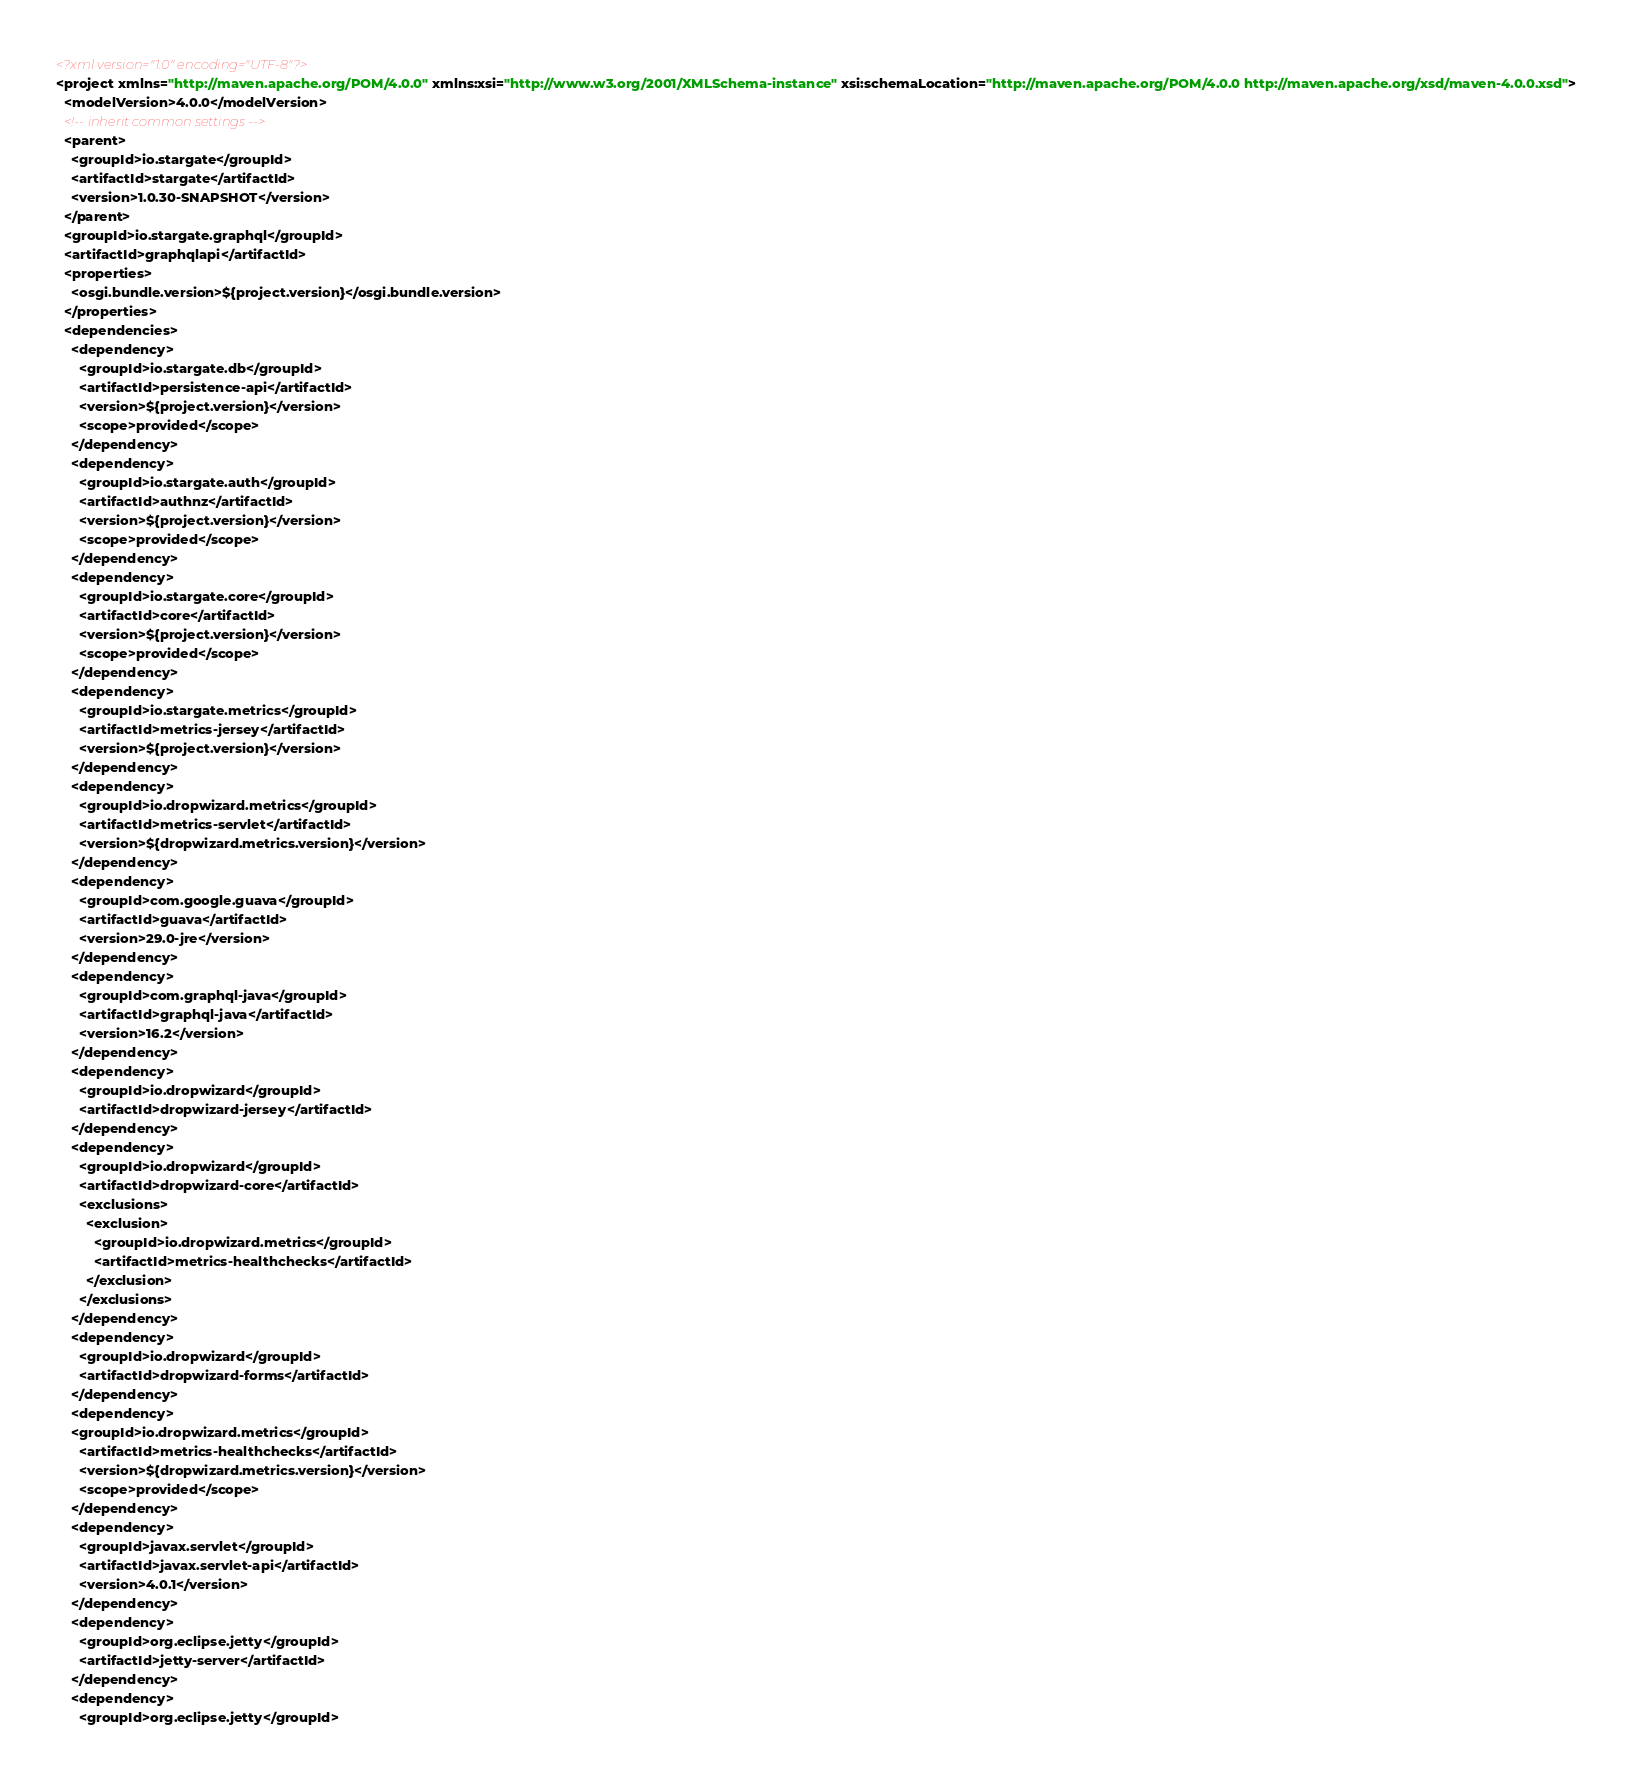<code> <loc_0><loc_0><loc_500><loc_500><_XML_><?xml version="1.0" encoding="UTF-8"?>
<project xmlns="http://maven.apache.org/POM/4.0.0" xmlns:xsi="http://www.w3.org/2001/XMLSchema-instance" xsi:schemaLocation="http://maven.apache.org/POM/4.0.0 http://maven.apache.org/xsd/maven-4.0.0.xsd">
  <modelVersion>4.0.0</modelVersion>
  <!-- inherit common settings -->
  <parent>
    <groupId>io.stargate</groupId>
    <artifactId>stargate</artifactId>
    <version>1.0.30-SNAPSHOT</version>
  </parent>
  <groupId>io.stargate.graphql</groupId>
  <artifactId>graphqlapi</artifactId>
  <properties>
    <osgi.bundle.version>${project.version}</osgi.bundle.version>
  </properties>
  <dependencies>
    <dependency>
      <groupId>io.stargate.db</groupId>
      <artifactId>persistence-api</artifactId>
      <version>${project.version}</version>
      <scope>provided</scope>
    </dependency>
    <dependency>
      <groupId>io.stargate.auth</groupId>
      <artifactId>authnz</artifactId>
      <version>${project.version}</version>
      <scope>provided</scope>
    </dependency>
    <dependency>
      <groupId>io.stargate.core</groupId>
      <artifactId>core</artifactId>
      <version>${project.version}</version>
      <scope>provided</scope>
    </dependency>
    <dependency>
      <groupId>io.stargate.metrics</groupId>
      <artifactId>metrics-jersey</artifactId>
      <version>${project.version}</version>
    </dependency>
    <dependency>
      <groupId>io.dropwizard.metrics</groupId>
      <artifactId>metrics-servlet</artifactId>
      <version>${dropwizard.metrics.version}</version>
    </dependency>
    <dependency>
      <groupId>com.google.guava</groupId>
      <artifactId>guava</artifactId>
      <version>29.0-jre</version>
    </dependency>
    <dependency>
      <groupId>com.graphql-java</groupId>
      <artifactId>graphql-java</artifactId>
      <version>16.2</version>
    </dependency>
    <dependency>
      <groupId>io.dropwizard</groupId>
      <artifactId>dropwizard-jersey</artifactId>
    </dependency>
    <dependency>
      <groupId>io.dropwizard</groupId>
      <artifactId>dropwizard-core</artifactId>
      <exclusions>
        <exclusion>
          <groupId>io.dropwizard.metrics</groupId>
          <artifactId>metrics-healthchecks</artifactId>
        </exclusion>
      </exclusions>
    </dependency>
    <dependency>
      <groupId>io.dropwizard</groupId>
      <artifactId>dropwizard-forms</artifactId>
    </dependency>
    <dependency>
    <groupId>io.dropwizard.metrics</groupId>
      <artifactId>metrics-healthchecks</artifactId>
      <version>${dropwizard.metrics.version}</version>
      <scope>provided</scope>
    </dependency>
    <dependency>
      <groupId>javax.servlet</groupId>
      <artifactId>javax.servlet-api</artifactId>
      <version>4.0.1</version>
    </dependency>
    <dependency>
      <groupId>org.eclipse.jetty</groupId>
      <artifactId>jetty-server</artifactId>
    </dependency>
    <dependency>
      <groupId>org.eclipse.jetty</groupId></code> 